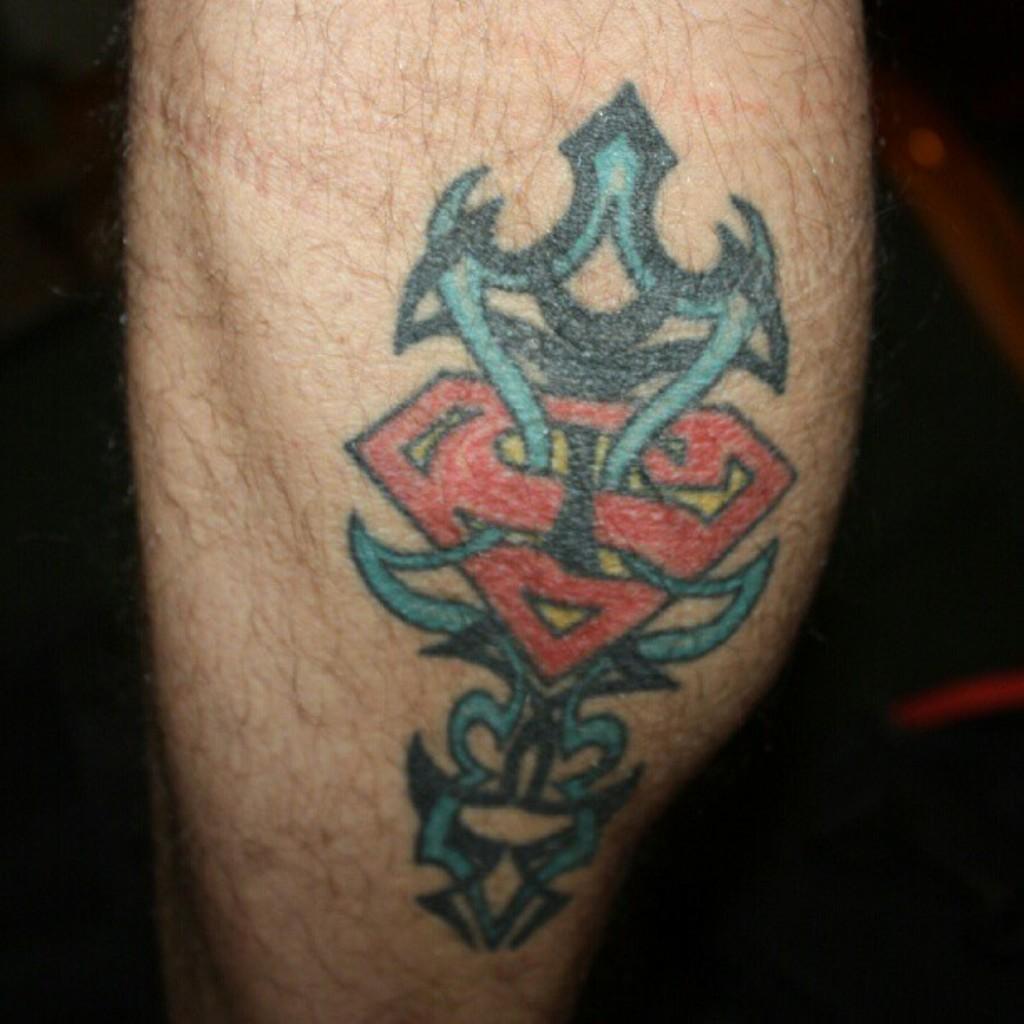Can you describe this image briefly? We can see leg of a person with tattoo. In the background it is dark. 